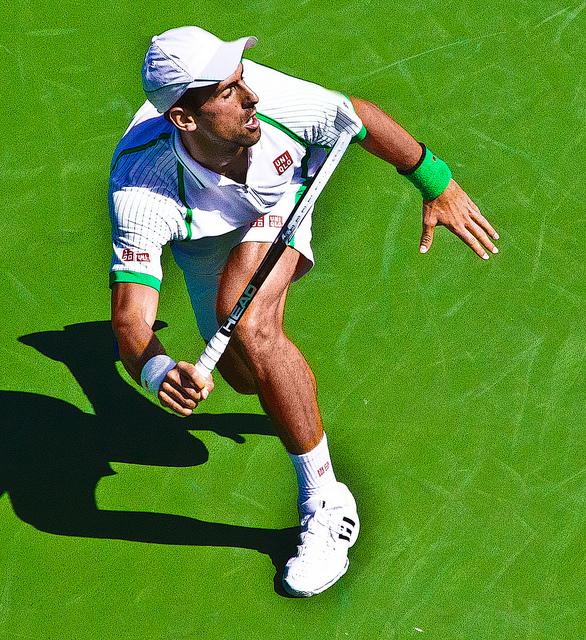What is the man doing?
Short answer required. Playing tennis. Is the man working hard?
Short answer required. Yes. Is the man facing the sun?
Concise answer only. Yes. 